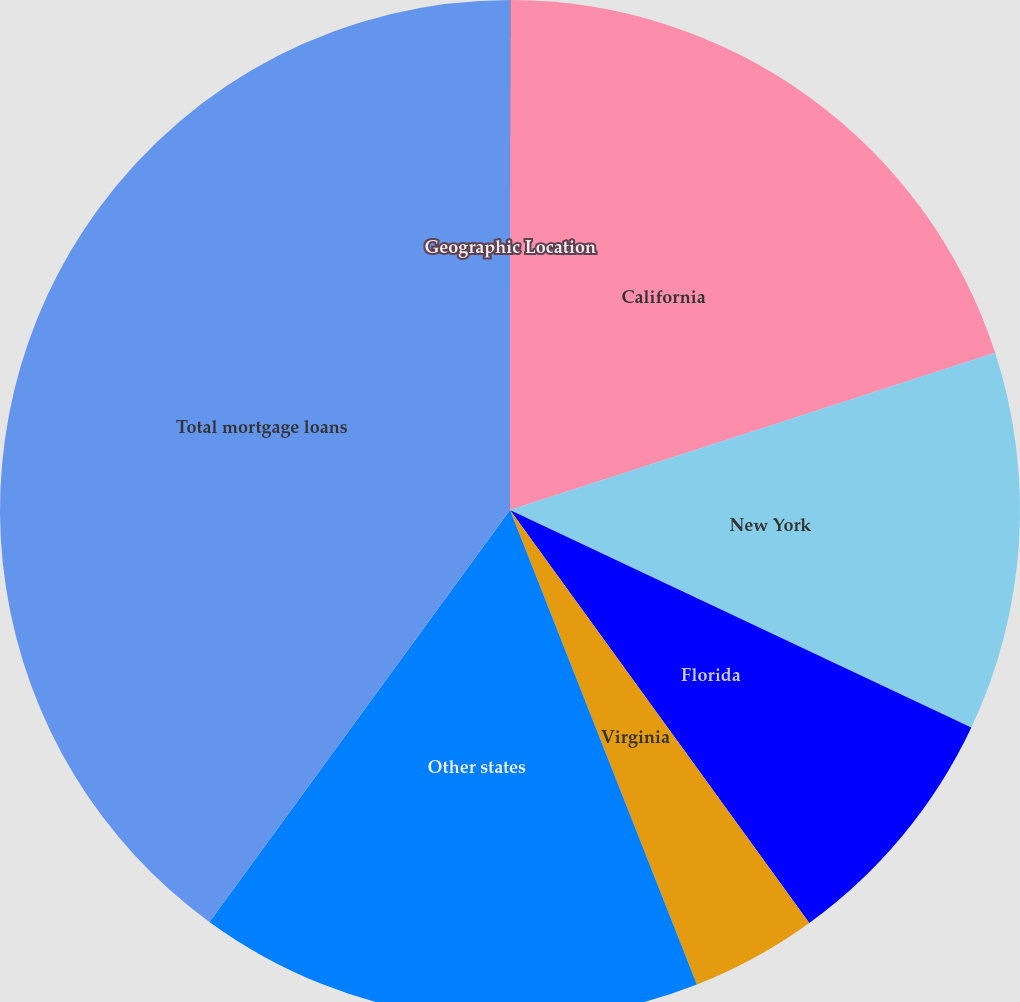Convert chart. <chart><loc_0><loc_0><loc_500><loc_500><pie_chart><fcel>Geographic Location<fcel>California<fcel>New York<fcel>Florida<fcel>Virginia<fcel>Other states<fcel>Total mortgage loans<nl><fcel>0.02%<fcel>19.99%<fcel>12.0%<fcel>8.01%<fcel>4.01%<fcel>16.0%<fcel>39.97%<nl></chart> 